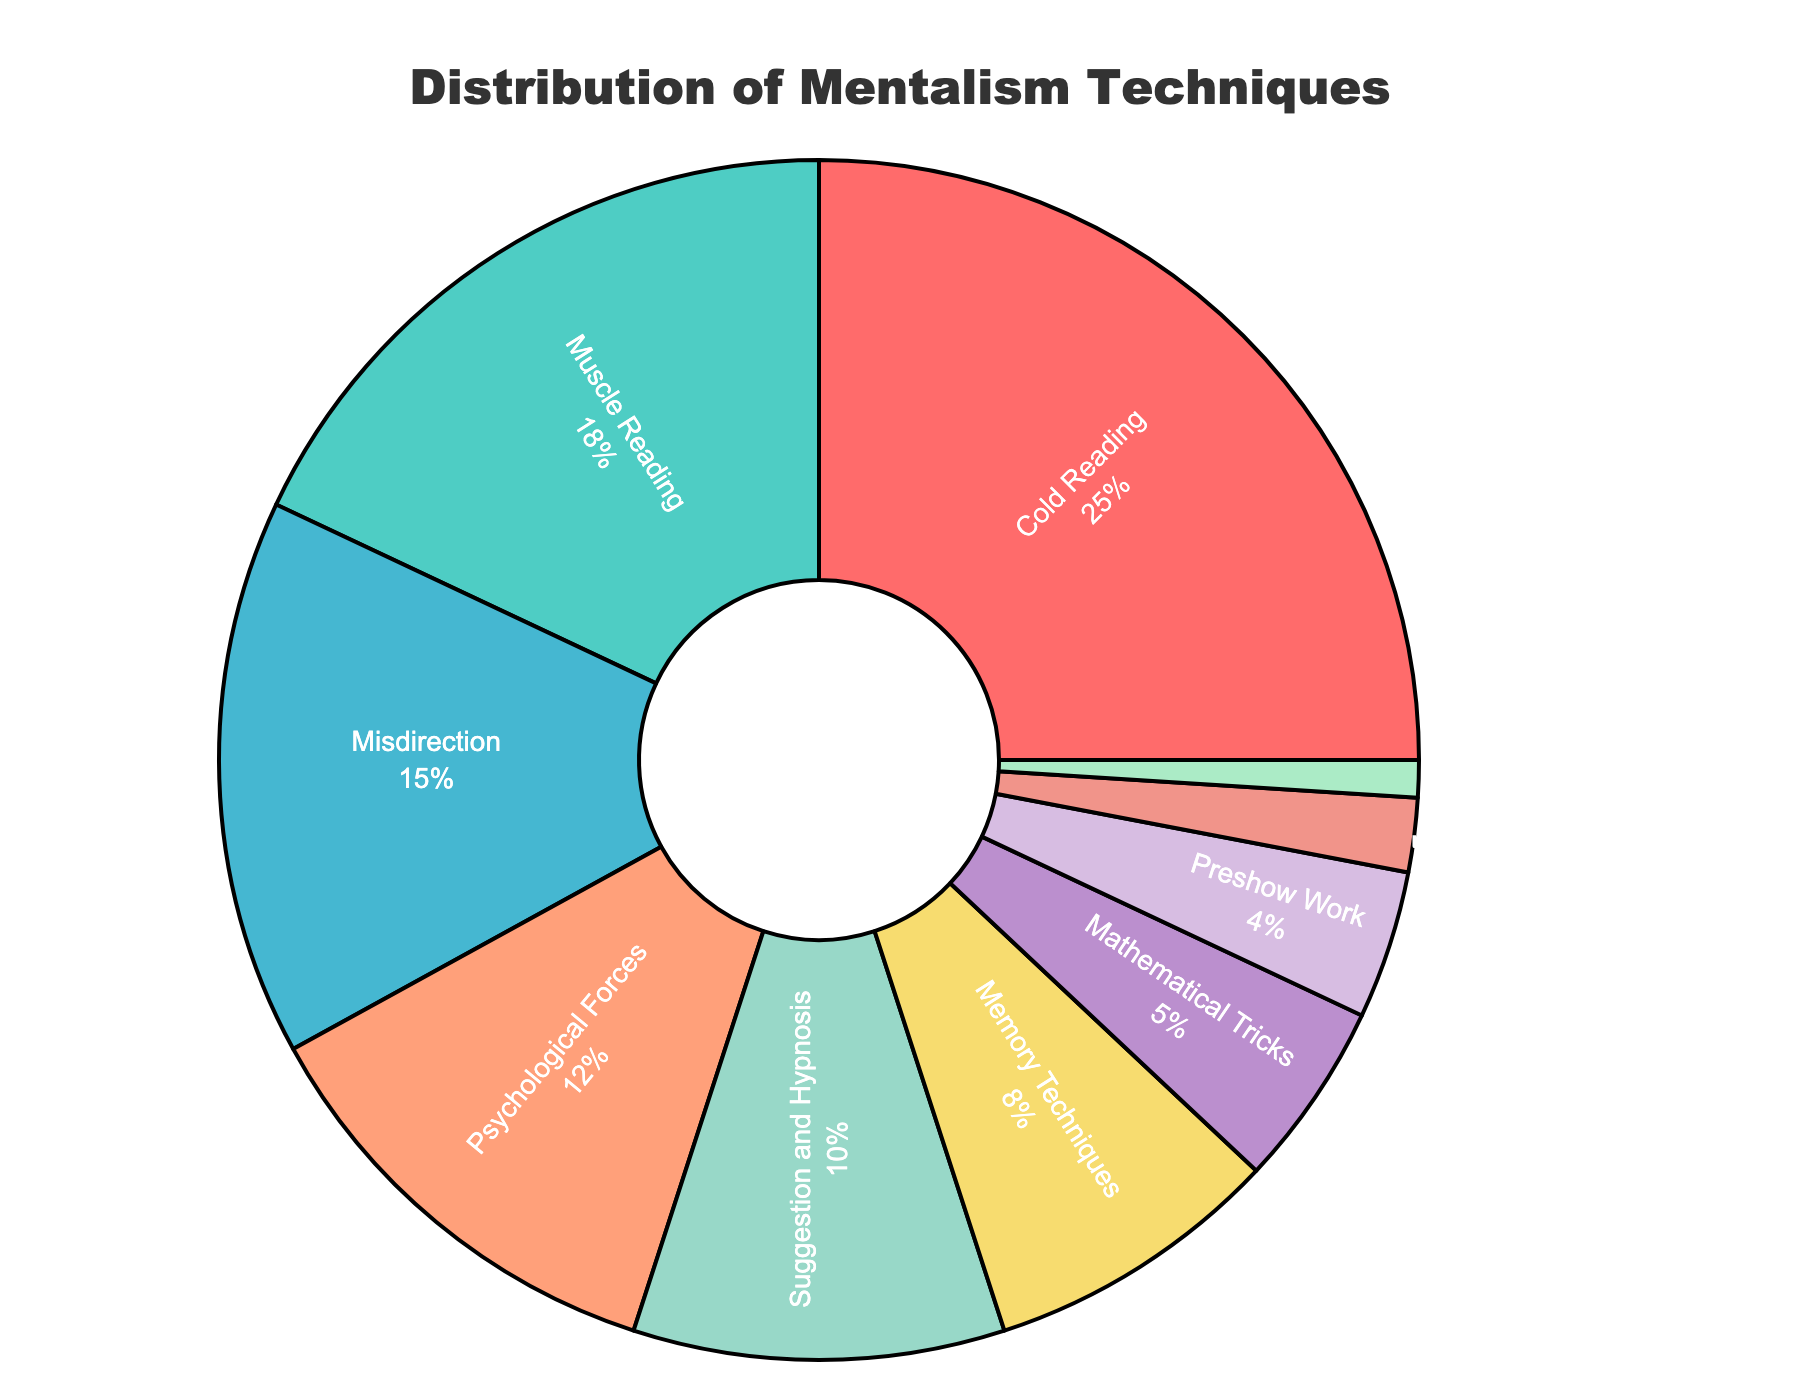What's the most used mentalism technique? To find the most used mentalism technique, look for the segment with the largest percentage in the pie chart. The segment labeled "Cold Reading" has the highest percentage.
Answer: Cold Reading How many techniques account for more than 10% each? Identify the segments that have a percentage greater than 10%. The techniques that satisfy this condition are Cold Reading (25%), Muscle Reading (18%), Misdirection (15%), and Psychological Forces (12%).
Answer: 4 Which technique has the smallest share? The smallest segment in the pie chart represents the technique with the least percentage. This is labeled "Equivoque" with 1%.
Answer: Equivoque What's the difference in percentage between Cold Reading and Muscle Reading? Subtract the percentage of Muscle Reading from the percentage of Cold Reading. Cold Reading is 25% and Muscle Reading is 18%, so 25% - 18% = 7%.
Answer: 7% What is the cumulative percentage of the three least used techniques? Add the percentages of Dual Reality (2%), Preshow Work (4%), and Equivoque (1%). 2% + 4% + 1% = 7%.
Answer: 7% Between Memory Techniques and Mathematical Tricks, which technique is less used and by how much? Compare the percentages of Memory Techniques (8%) and Mathematical Tricks (5%). Memory Techniques is 8% and Mathematical Tricks is 5%, so Mathematical Tricks is used 3% less.
Answer: Mathematical Tricks by 3% How many techniques have a usage percentage greater than 5%? Count the segments that have percentages greater than 5%. These techniques are Cold Reading, Muscle Reading, Misdirection, Psychological Forces, Suggestion and Hypnosis, and Memory Techniques.
Answer: 6 What color represents the Suggestion and Hypnosis segment? Locate the Suggestion and Hypnosis label and note its color. The segment representing Suggestion and Hypnosis is marked in yellow.
Answer: Yellow Which two techniques together make up nearly one-third of the distribution? Since "one-third" approximates 33.33%, identify two segments whose summed percentages are close to this value. Summing Misdirection (15%) and Psychological Forces (12%) gives 27%, which is not close enough. However, Cold Reading (25%) and one smaller segment like Memory Techniques (8%) sum to 33%.
Answer: Cold Reading and Memory Techniques What percentage of the techniques combined account for Misdirection and Psychological Forces? Add the percentages of Misdirection (15%) and Psychological Forces (12%). Sum them up to get 27%.
Answer: 27% 